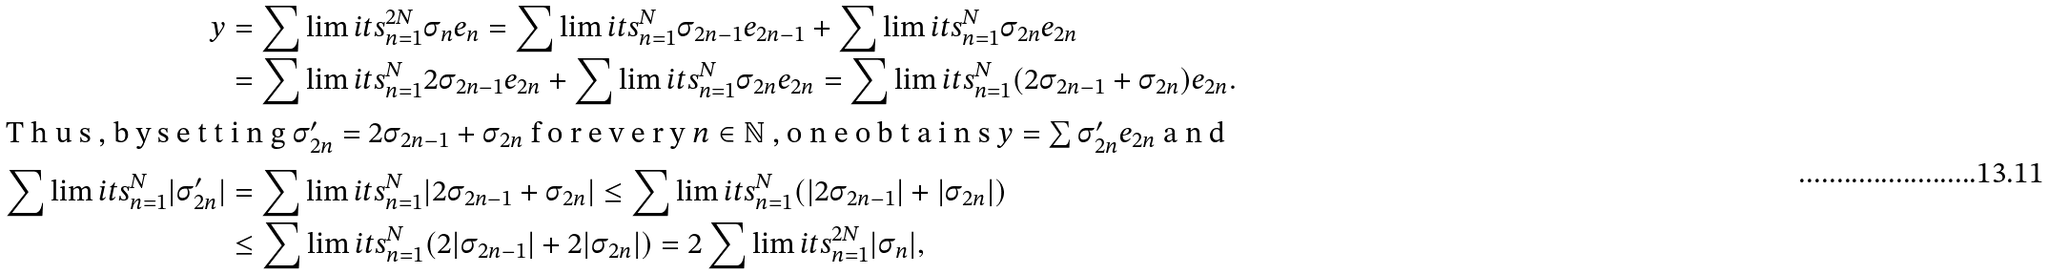<formula> <loc_0><loc_0><loc_500><loc_500>y & = \sum \lim i t s _ { n = 1 } ^ { 2 N } \sigma _ { n } e _ { n } = \sum \lim i t s _ { n = 1 } ^ { N } \sigma _ { 2 n - 1 } e _ { 2 n - 1 } + \sum \lim i t s _ { n = 1 } ^ { N } \sigma _ { 2 n } e _ { 2 n } \\ & = \sum \lim i t s _ { n = 1 } ^ { N } 2 \sigma _ { 2 n - 1 } e _ { 2 n } + \sum \lim i t s _ { n = 1 } ^ { N } \sigma _ { 2 n } e _ { 2 n } = \sum \lim i t s _ { n = 1 } ^ { N } ( 2 \sigma _ { 2 n - 1 } + \sigma _ { 2 n } ) e _ { 2 n } . \intertext { T h u s , b y s e t t i n g $ \sigma ^ { \prime } _ { 2 n } = 2 \sigma _ { 2 n - 1 } + \sigma _ { 2 n } $ f o r e v e r y $ n \in \mathbb { N } $ , o n e o b t a i n s $ y = \sum \sigma ^ { \prime } _ { 2 n } e _ { 2 n } $ a n d } \sum \lim i t s _ { n = 1 } ^ { N } | \sigma ^ { \prime } _ { 2 n } | & = \sum \lim i t s _ { n = 1 } ^ { N } | 2 \sigma _ { 2 n - 1 } + \sigma _ { 2 n } | \leq \sum \lim i t s _ { n = 1 } ^ { N } ( | 2 \sigma _ { 2 n - 1 } | + | \sigma _ { 2 n } | ) \\ & \leq \sum \lim i t s _ { n = 1 } ^ { N } ( 2 | \sigma _ { 2 n - 1 } | + 2 | \sigma _ { 2 n } | ) = 2 \sum \lim i t s _ { n = 1 } ^ { 2 N } | \sigma _ { n } | ,</formula> 